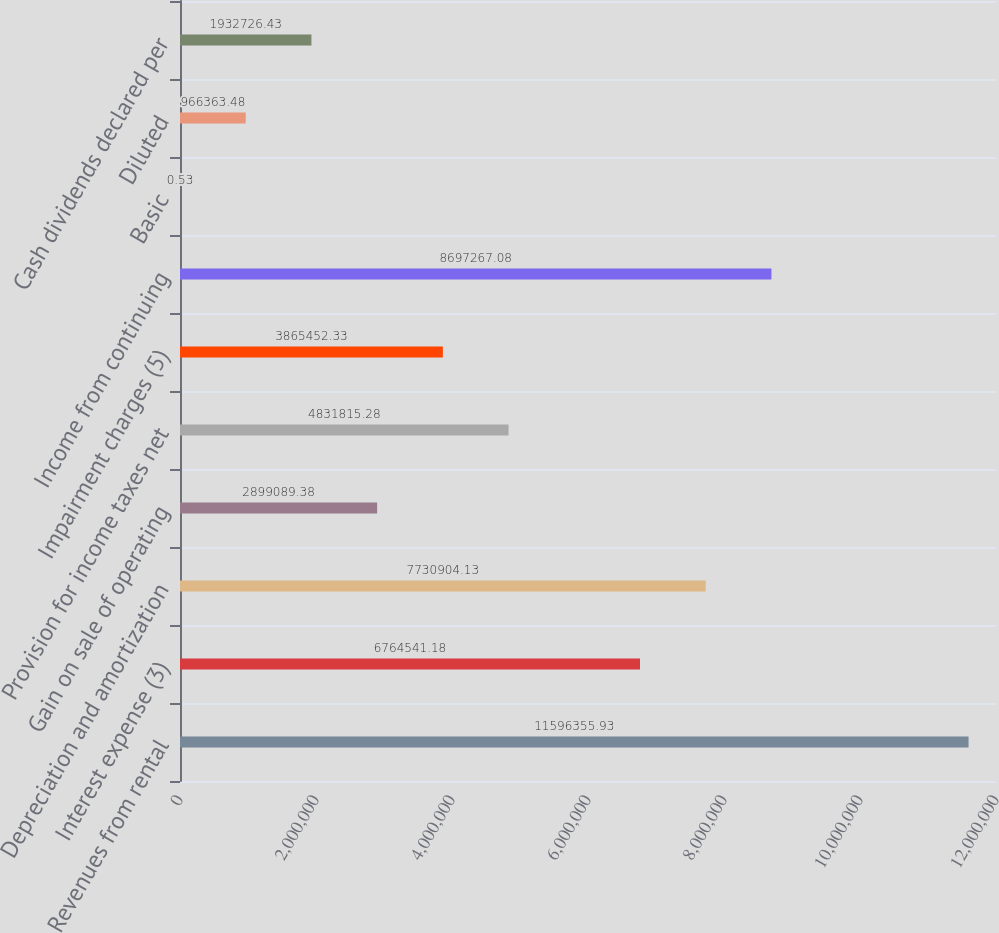<chart> <loc_0><loc_0><loc_500><loc_500><bar_chart><fcel>Revenues from rental<fcel>Interest expense (3)<fcel>Depreciation and amortization<fcel>Gain on sale of operating<fcel>Provision for income taxes net<fcel>Impairment charges (5)<fcel>Income from continuing<fcel>Basic<fcel>Diluted<fcel>Cash dividends declared per<nl><fcel>1.15964e+07<fcel>6.76454e+06<fcel>7.7309e+06<fcel>2.89909e+06<fcel>4.83182e+06<fcel>3.86545e+06<fcel>8.69727e+06<fcel>0.53<fcel>966363<fcel>1.93273e+06<nl></chart> 